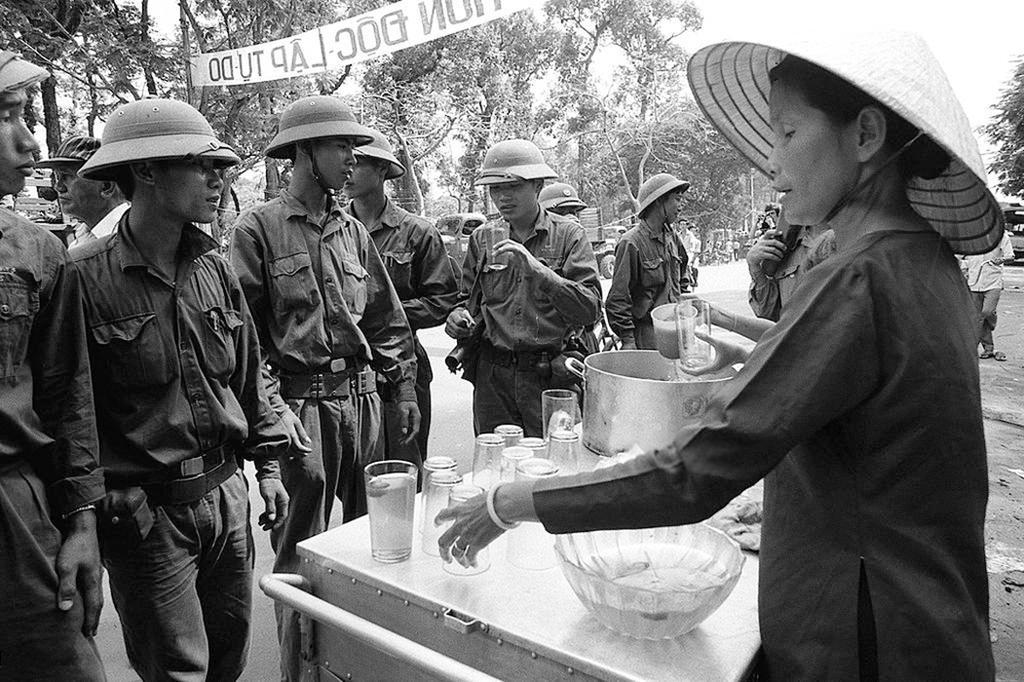Could you give a brief overview of what you see in this image? In this image I can see in the middle a group of men are standing, they are wearing shirts, trousers, helmets. On the right side there is a woman standing, at the top there are trees. 